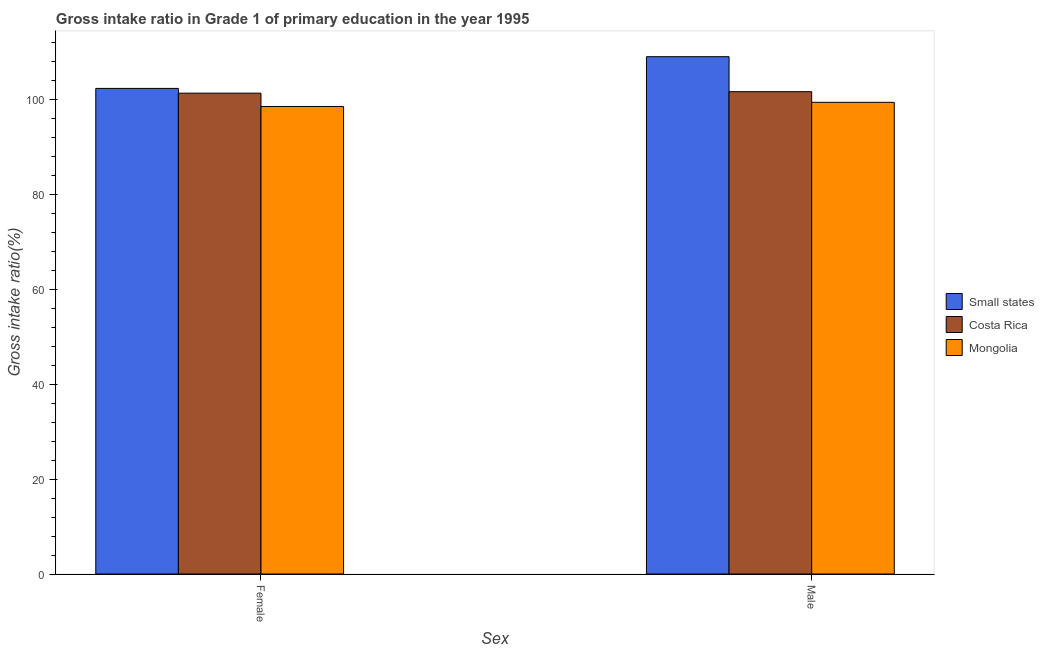How many different coloured bars are there?
Your answer should be very brief. 3. How many groups of bars are there?
Give a very brief answer. 2. Are the number of bars per tick equal to the number of legend labels?
Provide a succinct answer. Yes. What is the label of the 1st group of bars from the left?
Keep it short and to the point. Female. What is the gross intake ratio(female) in Mongolia?
Your response must be concise. 98.47. Across all countries, what is the maximum gross intake ratio(male)?
Offer a terse response. 108.97. Across all countries, what is the minimum gross intake ratio(male)?
Offer a very short reply. 99.36. In which country was the gross intake ratio(female) maximum?
Ensure brevity in your answer.  Small states. In which country was the gross intake ratio(female) minimum?
Offer a terse response. Mongolia. What is the total gross intake ratio(female) in the graph?
Ensure brevity in your answer.  302.04. What is the difference between the gross intake ratio(female) in Mongolia and that in Costa Rica?
Your response must be concise. -2.81. What is the difference between the gross intake ratio(male) in Small states and the gross intake ratio(female) in Costa Rica?
Offer a terse response. 7.68. What is the average gross intake ratio(male) per country?
Make the answer very short. 103.31. What is the difference between the gross intake ratio(female) and gross intake ratio(male) in Costa Rica?
Your answer should be compact. -0.31. In how many countries, is the gross intake ratio(female) greater than 108 %?
Offer a terse response. 0. What is the ratio of the gross intake ratio(female) in Mongolia to that in Costa Rica?
Provide a succinct answer. 0.97. In how many countries, is the gross intake ratio(female) greater than the average gross intake ratio(female) taken over all countries?
Provide a succinct answer. 2. What does the 3rd bar from the left in Female represents?
Offer a very short reply. Mongolia. How many bars are there?
Your response must be concise. 6. Are all the bars in the graph horizontal?
Your response must be concise. No. How many legend labels are there?
Your answer should be very brief. 3. How are the legend labels stacked?
Ensure brevity in your answer.  Vertical. What is the title of the graph?
Ensure brevity in your answer.  Gross intake ratio in Grade 1 of primary education in the year 1995. What is the label or title of the X-axis?
Offer a very short reply. Sex. What is the label or title of the Y-axis?
Your answer should be very brief. Gross intake ratio(%). What is the Gross intake ratio(%) in Small states in Female?
Your response must be concise. 102.29. What is the Gross intake ratio(%) in Costa Rica in Female?
Provide a succinct answer. 101.28. What is the Gross intake ratio(%) of Mongolia in Female?
Offer a terse response. 98.47. What is the Gross intake ratio(%) in Small states in Male?
Your response must be concise. 108.97. What is the Gross intake ratio(%) of Costa Rica in Male?
Give a very brief answer. 101.6. What is the Gross intake ratio(%) in Mongolia in Male?
Your response must be concise. 99.36. Across all Sex, what is the maximum Gross intake ratio(%) in Small states?
Provide a short and direct response. 108.97. Across all Sex, what is the maximum Gross intake ratio(%) in Costa Rica?
Ensure brevity in your answer.  101.6. Across all Sex, what is the maximum Gross intake ratio(%) in Mongolia?
Keep it short and to the point. 99.36. Across all Sex, what is the minimum Gross intake ratio(%) of Small states?
Provide a short and direct response. 102.29. Across all Sex, what is the minimum Gross intake ratio(%) in Costa Rica?
Give a very brief answer. 101.28. Across all Sex, what is the minimum Gross intake ratio(%) of Mongolia?
Keep it short and to the point. 98.47. What is the total Gross intake ratio(%) in Small states in the graph?
Offer a very short reply. 211.26. What is the total Gross intake ratio(%) in Costa Rica in the graph?
Offer a terse response. 202.88. What is the total Gross intake ratio(%) in Mongolia in the graph?
Your response must be concise. 197.83. What is the difference between the Gross intake ratio(%) of Small states in Female and that in Male?
Give a very brief answer. -6.68. What is the difference between the Gross intake ratio(%) in Costa Rica in Female and that in Male?
Provide a succinct answer. -0.31. What is the difference between the Gross intake ratio(%) of Mongolia in Female and that in Male?
Provide a short and direct response. -0.89. What is the difference between the Gross intake ratio(%) in Small states in Female and the Gross intake ratio(%) in Costa Rica in Male?
Make the answer very short. 0.69. What is the difference between the Gross intake ratio(%) in Small states in Female and the Gross intake ratio(%) in Mongolia in Male?
Offer a very short reply. 2.93. What is the difference between the Gross intake ratio(%) of Costa Rica in Female and the Gross intake ratio(%) of Mongolia in Male?
Offer a terse response. 1.93. What is the average Gross intake ratio(%) of Small states per Sex?
Offer a terse response. 105.63. What is the average Gross intake ratio(%) of Costa Rica per Sex?
Offer a very short reply. 101.44. What is the average Gross intake ratio(%) of Mongolia per Sex?
Your answer should be very brief. 98.91. What is the difference between the Gross intake ratio(%) in Small states and Gross intake ratio(%) in Mongolia in Female?
Your answer should be very brief. 3.82. What is the difference between the Gross intake ratio(%) in Costa Rica and Gross intake ratio(%) in Mongolia in Female?
Make the answer very short. 2.81. What is the difference between the Gross intake ratio(%) in Small states and Gross intake ratio(%) in Costa Rica in Male?
Provide a short and direct response. 7.37. What is the difference between the Gross intake ratio(%) of Small states and Gross intake ratio(%) of Mongolia in Male?
Make the answer very short. 9.61. What is the difference between the Gross intake ratio(%) in Costa Rica and Gross intake ratio(%) in Mongolia in Male?
Your answer should be compact. 2.24. What is the ratio of the Gross intake ratio(%) in Small states in Female to that in Male?
Provide a succinct answer. 0.94. What is the ratio of the Gross intake ratio(%) of Costa Rica in Female to that in Male?
Your answer should be very brief. 1. What is the ratio of the Gross intake ratio(%) of Mongolia in Female to that in Male?
Offer a very short reply. 0.99. What is the difference between the highest and the second highest Gross intake ratio(%) of Small states?
Make the answer very short. 6.68. What is the difference between the highest and the second highest Gross intake ratio(%) of Costa Rica?
Give a very brief answer. 0.31. What is the difference between the highest and the second highest Gross intake ratio(%) in Mongolia?
Your response must be concise. 0.89. What is the difference between the highest and the lowest Gross intake ratio(%) of Small states?
Offer a terse response. 6.68. What is the difference between the highest and the lowest Gross intake ratio(%) in Costa Rica?
Your response must be concise. 0.31. What is the difference between the highest and the lowest Gross intake ratio(%) of Mongolia?
Offer a terse response. 0.89. 